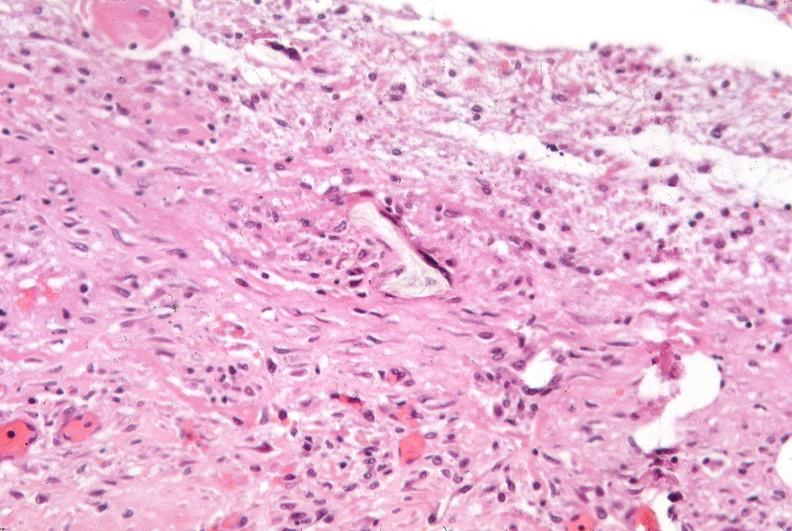was talc used to sclerose emphysematous lung, alpha-1 antitrypsin deficiency?
Answer the question using a single word or phrase. Yes 